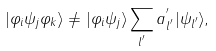<formula> <loc_0><loc_0><loc_500><loc_500>| \varphi _ { i } \psi _ { j } \varphi _ { k } \rangle \neq | \varphi _ { i } \psi _ { j } \rangle \sum _ { l ^ { ^ { \prime } } } a ^ { ^ { \prime } } _ { l ^ { ^ { \prime } } } | \psi _ { l ^ { ^ { \prime } } } \rangle ,</formula> 